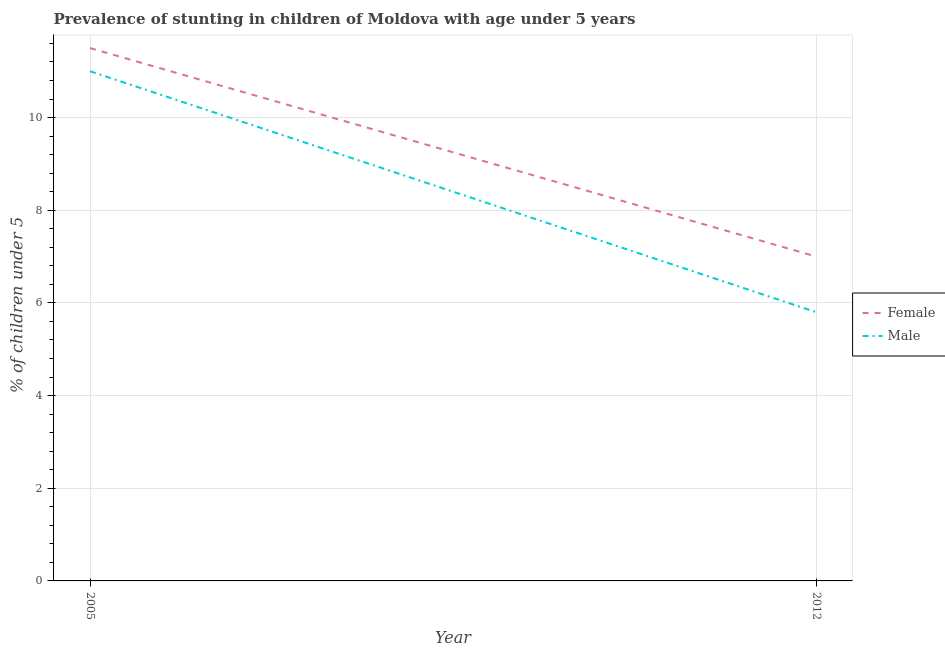What is the percentage of stunted male children in 2012?
Ensure brevity in your answer.  5.8. Across all years, what is the maximum percentage of stunted female children?
Ensure brevity in your answer.  11.5. Across all years, what is the minimum percentage of stunted male children?
Ensure brevity in your answer.  5.8. In which year was the percentage of stunted male children maximum?
Ensure brevity in your answer.  2005. What is the total percentage of stunted male children in the graph?
Your answer should be compact. 16.8. What is the difference between the percentage of stunted female children in 2005 and the percentage of stunted male children in 2012?
Keep it short and to the point. 5.7. What is the average percentage of stunted male children per year?
Give a very brief answer. 8.4. In the year 2005, what is the difference between the percentage of stunted female children and percentage of stunted male children?
Offer a terse response. 0.5. In how many years, is the percentage of stunted male children greater than 10.4 %?
Give a very brief answer. 1. What is the ratio of the percentage of stunted female children in 2005 to that in 2012?
Your answer should be very brief. 1.64. Does the percentage of stunted male children monotonically increase over the years?
Keep it short and to the point. No. How many lines are there?
Your response must be concise. 2. What is the difference between two consecutive major ticks on the Y-axis?
Your answer should be compact. 2. Are the values on the major ticks of Y-axis written in scientific E-notation?
Make the answer very short. No. Does the graph contain grids?
Your answer should be compact. Yes. Where does the legend appear in the graph?
Your answer should be compact. Center right. How are the legend labels stacked?
Your answer should be very brief. Vertical. What is the title of the graph?
Keep it short and to the point. Prevalence of stunting in children of Moldova with age under 5 years. What is the label or title of the X-axis?
Provide a succinct answer. Year. What is the label or title of the Y-axis?
Ensure brevity in your answer.   % of children under 5. What is the  % of children under 5 in Male in 2005?
Your response must be concise. 11. What is the  % of children under 5 of Female in 2012?
Keep it short and to the point. 7. What is the  % of children under 5 of Male in 2012?
Offer a very short reply. 5.8. Across all years, what is the minimum  % of children under 5 of Female?
Offer a terse response. 7. Across all years, what is the minimum  % of children under 5 of Male?
Provide a short and direct response. 5.8. What is the total  % of children under 5 of Male in the graph?
Keep it short and to the point. 16.8. What is the difference between the  % of children under 5 of Female in 2005 and that in 2012?
Keep it short and to the point. 4.5. What is the difference between the  % of children under 5 in Male in 2005 and that in 2012?
Provide a succinct answer. 5.2. What is the average  % of children under 5 of Female per year?
Provide a short and direct response. 9.25. In the year 2005, what is the difference between the  % of children under 5 in Female and  % of children under 5 in Male?
Ensure brevity in your answer.  0.5. In the year 2012, what is the difference between the  % of children under 5 in Female and  % of children under 5 in Male?
Make the answer very short. 1.2. What is the ratio of the  % of children under 5 in Female in 2005 to that in 2012?
Your answer should be compact. 1.64. What is the ratio of the  % of children under 5 in Male in 2005 to that in 2012?
Your answer should be compact. 1.9. What is the difference between the highest and the second highest  % of children under 5 of Female?
Offer a terse response. 4.5. What is the difference between the highest and the second highest  % of children under 5 of Male?
Provide a succinct answer. 5.2. What is the difference between the highest and the lowest  % of children under 5 of Female?
Ensure brevity in your answer.  4.5. What is the difference between the highest and the lowest  % of children under 5 of Male?
Your answer should be very brief. 5.2. 